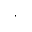Convert formula to latex. <formula><loc_0><loc_0><loc_500><loc_500>\cdot</formula> 